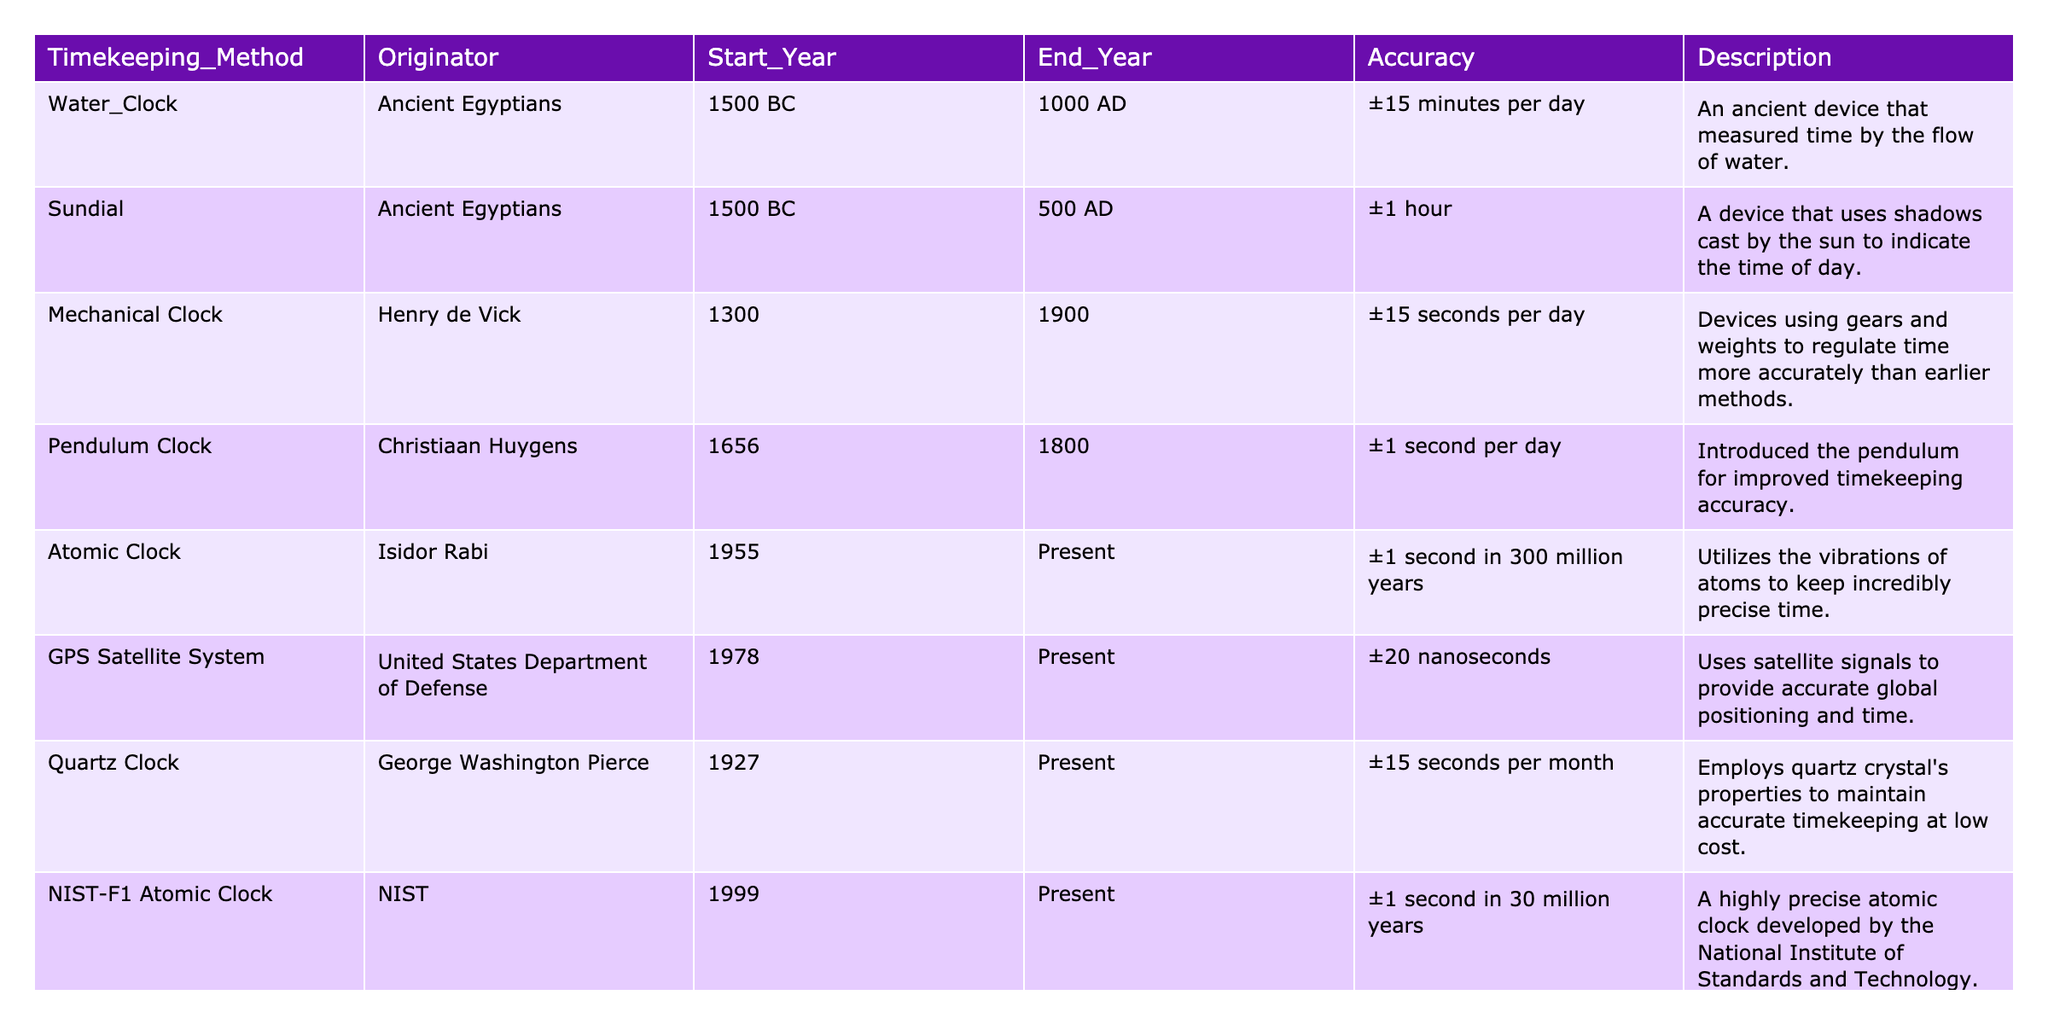What is the accuracy of the Atomic Clock? The table lists the accuracy for the Atomic Clock as ±1 second in 300 million years.
Answer: ±1 second in 300 million years Who originated the Pendulum Clock? According to the table, the Pendulum Clock was originated by Christiaan Huygens.
Answer: Christiaan Huygens What timekeeping method has the highest accuracy? The GPS Satellite System has the highest accuracy with ±20 nanoseconds, which is more precise than other methods listed.
Answer: GPS Satellite System Which timekeeping method was used from 1500 BC to 500 AD? Both the Water Clock and Sundial were in use during that period, but only the Sundial is mentioned for that specific range.
Answer: Sundial How many years did the Mechanical Clock span in use? The Mechanical Clock was in use from 1300 to 1900, which is a total of 600 years (1900 - 1300).
Answer: 600 years Is the Quartz Clock older than the NIST-F1 Atomic Clock? The Quartz Clock started in 1927, while the NIST-F1 Atomic Clock began in 1999, making the Quartz Clock older.
Answer: Yes What is the average accuracy of the clocks listed in the table? The average accuracy can be calculated by converting each accuracy measure to a common time format, which requires multiple steps of calculation and conversion leading to an approximate average accuracy.
Answer: Approximate average accuracy needs calculation Which timekeeping method is the most recent invention? The NIST-F1 Atomic Clock started in 1999, making it the most recent compared to other methods in the table.
Answer: NIST-F1 Atomic Clock What device measures time by the flow of water? The Water Clock is described as a device that measures time by the flow of water.
Answer: Water Clock What are the start and end years for the Sundial? According to the table, the Sundial was used from 1500 BC to 500 AD.
Answer: 1500 BC to 500 AD 